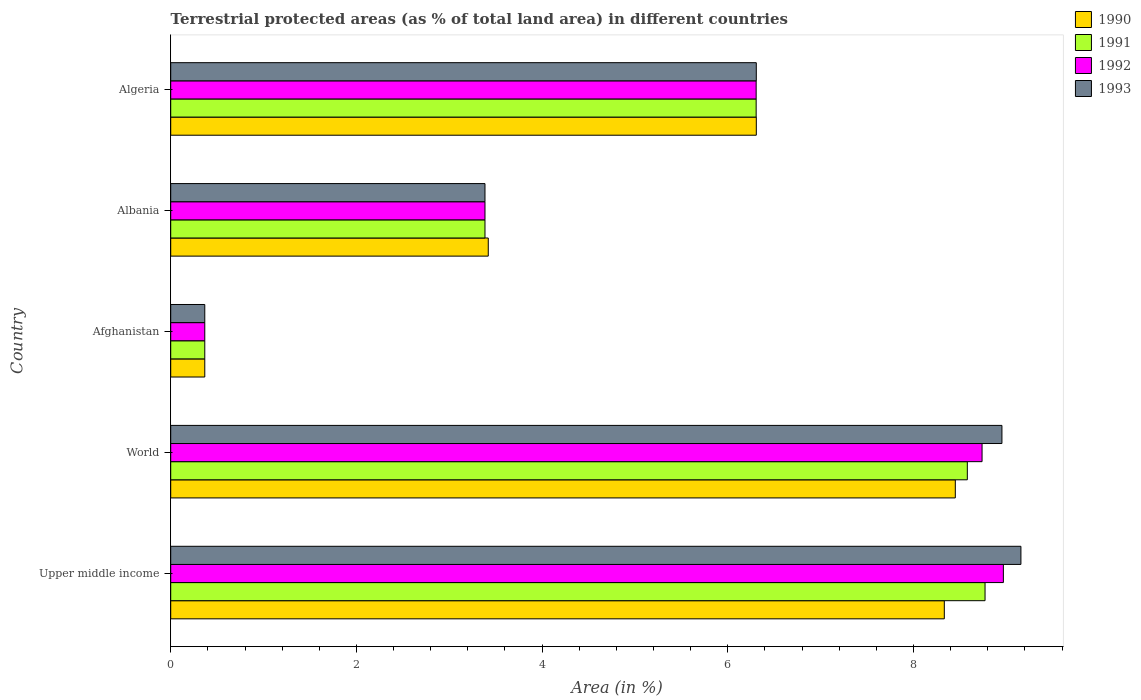How many different coloured bars are there?
Give a very brief answer. 4. How many bars are there on the 5th tick from the top?
Give a very brief answer. 4. How many bars are there on the 2nd tick from the bottom?
Make the answer very short. 4. What is the label of the 3rd group of bars from the top?
Ensure brevity in your answer.  Afghanistan. What is the percentage of terrestrial protected land in 1990 in Algeria?
Your response must be concise. 6.31. Across all countries, what is the maximum percentage of terrestrial protected land in 1990?
Offer a very short reply. 8.45. Across all countries, what is the minimum percentage of terrestrial protected land in 1993?
Keep it short and to the point. 0.37. In which country was the percentage of terrestrial protected land in 1993 maximum?
Make the answer very short. Upper middle income. In which country was the percentage of terrestrial protected land in 1991 minimum?
Provide a succinct answer. Afghanistan. What is the total percentage of terrestrial protected land in 1992 in the graph?
Offer a very short reply. 27.76. What is the difference between the percentage of terrestrial protected land in 1992 in Albania and that in World?
Offer a very short reply. -5.35. What is the difference between the percentage of terrestrial protected land in 1993 in Afghanistan and the percentage of terrestrial protected land in 1992 in Algeria?
Provide a short and direct response. -5.94. What is the average percentage of terrestrial protected land in 1992 per country?
Ensure brevity in your answer.  5.55. What is the difference between the percentage of terrestrial protected land in 1992 and percentage of terrestrial protected land in 1991 in Albania?
Offer a very short reply. 0. What is the ratio of the percentage of terrestrial protected land in 1991 in Upper middle income to that in World?
Give a very brief answer. 1.02. Is the percentage of terrestrial protected land in 1991 in Afghanistan less than that in Upper middle income?
Provide a short and direct response. Yes. What is the difference between the highest and the second highest percentage of terrestrial protected land in 1990?
Offer a terse response. 0.12. What is the difference between the highest and the lowest percentage of terrestrial protected land in 1990?
Give a very brief answer. 8.08. Is the sum of the percentage of terrestrial protected land in 1990 in Albania and World greater than the maximum percentage of terrestrial protected land in 1992 across all countries?
Ensure brevity in your answer.  Yes. Is it the case that in every country, the sum of the percentage of terrestrial protected land in 1990 and percentage of terrestrial protected land in 1993 is greater than the sum of percentage of terrestrial protected land in 1992 and percentage of terrestrial protected land in 1991?
Your response must be concise. No. What does the 1st bar from the top in Algeria represents?
Provide a succinct answer. 1993. What is the difference between two consecutive major ticks on the X-axis?
Offer a very short reply. 2. Are the values on the major ticks of X-axis written in scientific E-notation?
Your answer should be very brief. No. How many legend labels are there?
Your answer should be very brief. 4. What is the title of the graph?
Make the answer very short. Terrestrial protected areas (as % of total land area) in different countries. What is the label or title of the X-axis?
Keep it short and to the point. Area (in %). What is the label or title of the Y-axis?
Ensure brevity in your answer.  Country. What is the Area (in %) in 1990 in Upper middle income?
Give a very brief answer. 8.33. What is the Area (in %) of 1991 in Upper middle income?
Give a very brief answer. 8.77. What is the Area (in %) in 1992 in Upper middle income?
Offer a very short reply. 8.97. What is the Area (in %) of 1993 in Upper middle income?
Offer a very short reply. 9.16. What is the Area (in %) of 1990 in World?
Provide a succinct answer. 8.45. What is the Area (in %) in 1991 in World?
Offer a very short reply. 8.58. What is the Area (in %) of 1992 in World?
Offer a very short reply. 8.74. What is the Area (in %) in 1993 in World?
Ensure brevity in your answer.  8.95. What is the Area (in %) of 1990 in Afghanistan?
Provide a succinct answer. 0.37. What is the Area (in %) in 1991 in Afghanistan?
Your response must be concise. 0.37. What is the Area (in %) in 1992 in Afghanistan?
Give a very brief answer. 0.37. What is the Area (in %) of 1993 in Afghanistan?
Give a very brief answer. 0.37. What is the Area (in %) in 1990 in Albania?
Your answer should be very brief. 3.42. What is the Area (in %) of 1991 in Albania?
Your response must be concise. 3.38. What is the Area (in %) in 1992 in Albania?
Your response must be concise. 3.38. What is the Area (in %) of 1993 in Albania?
Provide a succinct answer. 3.38. What is the Area (in %) of 1990 in Algeria?
Make the answer very short. 6.31. What is the Area (in %) of 1991 in Algeria?
Offer a terse response. 6.31. What is the Area (in %) of 1992 in Algeria?
Ensure brevity in your answer.  6.31. What is the Area (in %) in 1993 in Algeria?
Give a very brief answer. 6.31. Across all countries, what is the maximum Area (in %) in 1990?
Make the answer very short. 8.45. Across all countries, what is the maximum Area (in %) of 1991?
Provide a short and direct response. 8.77. Across all countries, what is the maximum Area (in %) of 1992?
Offer a very short reply. 8.97. Across all countries, what is the maximum Area (in %) of 1993?
Provide a short and direct response. 9.16. Across all countries, what is the minimum Area (in %) of 1990?
Your answer should be very brief. 0.37. Across all countries, what is the minimum Area (in %) of 1991?
Offer a terse response. 0.37. Across all countries, what is the minimum Area (in %) in 1992?
Provide a short and direct response. 0.37. Across all countries, what is the minimum Area (in %) of 1993?
Keep it short and to the point. 0.37. What is the total Area (in %) of 1990 in the graph?
Keep it short and to the point. 26.88. What is the total Area (in %) of 1991 in the graph?
Offer a very short reply. 27.41. What is the total Area (in %) in 1992 in the graph?
Provide a succinct answer. 27.76. What is the total Area (in %) in 1993 in the graph?
Give a very brief answer. 28.17. What is the difference between the Area (in %) in 1990 in Upper middle income and that in World?
Your response must be concise. -0.12. What is the difference between the Area (in %) of 1991 in Upper middle income and that in World?
Offer a very short reply. 0.19. What is the difference between the Area (in %) of 1992 in Upper middle income and that in World?
Your answer should be compact. 0.23. What is the difference between the Area (in %) of 1993 in Upper middle income and that in World?
Offer a terse response. 0.2. What is the difference between the Area (in %) of 1990 in Upper middle income and that in Afghanistan?
Your answer should be very brief. 7.97. What is the difference between the Area (in %) of 1991 in Upper middle income and that in Afghanistan?
Offer a terse response. 8.4. What is the difference between the Area (in %) of 1992 in Upper middle income and that in Afghanistan?
Your answer should be very brief. 8.6. What is the difference between the Area (in %) in 1993 in Upper middle income and that in Afghanistan?
Give a very brief answer. 8.79. What is the difference between the Area (in %) of 1990 in Upper middle income and that in Albania?
Ensure brevity in your answer.  4.91. What is the difference between the Area (in %) in 1991 in Upper middle income and that in Albania?
Ensure brevity in your answer.  5.39. What is the difference between the Area (in %) in 1992 in Upper middle income and that in Albania?
Ensure brevity in your answer.  5.58. What is the difference between the Area (in %) of 1993 in Upper middle income and that in Albania?
Your response must be concise. 5.77. What is the difference between the Area (in %) of 1990 in Upper middle income and that in Algeria?
Your answer should be very brief. 2.02. What is the difference between the Area (in %) of 1991 in Upper middle income and that in Algeria?
Your response must be concise. 2.47. What is the difference between the Area (in %) of 1992 in Upper middle income and that in Algeria?
Provide a succinct answer. 2.66. What is the difference between the Area (in %) in 1993 in Upper middle income and that in Algeria?
Offer a very short reply. 2.85. What is the difference between the Area (in %) in 1990 in World and that in Afghanistan?
Offer a very short reply. 8.08. What is the difference between the Area (in %) of 1991 in World and that in Afghanistan?
Keep it short and to the point. 8.21. What is the difference between the Area (in %) in 1992 in World and that in Afghanistan?
Provide a short and direct response. 8.37. What is the difference between the Area (in %) in 1993 in World and that in Afghanistan?
Provide a succinct answer. 8.59. What is the difference between the Area (in %) of 1990 in World and that in Albania?
Provide a short and direct response. 5.03. What is the difference between the Area (in %) in 1991 in World and that in Albania?
Offer a very short reply. 5.2. What is the difference between the Area (in %) of 1992 in World and that in Albania?
Your answer should be very brief. 5.35. What is the difference between the Area (in %) in 1993 in World and that in Albania?
Provide a short and direct response. 5.57. What is the difference between the Area (in %) of 1990 in World and that in Algeria?
Keep it short and to the point. 2.14. What is the difference between the Area (in %) of 1991 in World and that in Algeria?
Provide a short and direct response. 2.27. What is the difference between the Area (in %) of 1992 in World and that in Algeria?
Your response must be concise. 2.43. What is the difference between the Area (in %) in 1993 in World and that in Algeria?
Make the answer very short. 2.65. What is the difference between the Area (in %) in 1990 in Afghanistan and that in Albania?
Your answer should be very brief. -3.05. What is the difference between the Area (in %) in 1991 in Afghanistan and that in Albania?
Your response must be concise. -3.02. What is the difference between the Area (in %) in 1992 in Afghanistan and that in Albania?
Provide a short and direct response. -3.02. What is the difference between the Area (in %) in 1993 in Afghanistan and that in Albania?
Give a very brief answer. -3.02. What is the difference between the Area (in %) of 1990 in Afghanistan and that in Algeria?
Make the answer very short. -5.94. What is the difference between the Area (in %) in 1991 in Afghanistan and that in Algeria?
Ensure brevity in your answer.  -5.94. What is the difference between the Area (in %) of 1992 in Afghanistan and that in Algeria?
Keep it short and to the point. -5.94. What is the difference between the Area (in %) of 1993 in Afghanistan and that in Algeria?
Provide a short and direct response. -5.94. What is the difference between the Area (in %) in 1990 in Albania and that in Algeria?
Provide a short and direct response. -2.89. What is the difference between the Area (in %) of 1991 in Albania and that in Algeria?
Offer a very short reply. -2.92. What is the difference between the Area (in %) in 1992 in Albania and that in Algeria?
Provide a short and direct response. -2.92. What is the difference between the Area (in %) of 1993 in Albania and that in Algeria?
Provide a succinct answer. -2.92. What is the difference between the Area (in %) in 1990 in Upper middle income and the Area (in %) in 1991 in World?
Offer a very short reply. -0.25. What is the difference between the Area (in %) in 1990 in Upper middle income and the Area (in %) in 1992 in World?
Provide a short and direct response. -0.41. What is the difference between the Area (in %) of 1990 in Upper middle income and the Area (in %) of 1993 in World?
Your response must be concise. -0.62. What is the difference between the Area (in %) of 1991 in Upper middle income and the Area (in %) of 1992 in World?
Give a very brief answer. 0.03. What is the difference between the Area (in %) in 1991 in Upper middle income and the Area (in %) in 1993 in World?
Keep it short and to the point. -0.18. What is the difference between the Area (in %) in 1992 in Upper middle income and the Area (in %) in 1993 in World?
Your response must be concise. 0.02. What is the difference between the Area (in %) of 1990 in Upper middle income and the Area (in %) of 1991 in Afghanistan?
Your response must be concise. 7.97. What is the difference between the Area (in %) in 1990 in Upper middle income and the Area (in %) in 1992 in Afghanistan?
Provide a short and direct response. 7.97. What is the difference between the Area (in %) in 1990 in Upper middle income and the Area (in %) in 1993 in Afghanistan?
Your response must be concise. 7.97. What is the difference between the Area (in %) of 1991 in Upper middle income and the Area (in %) of 1992 in Afghanistan?
Offer a very short reply. 8.4. What is the difference between the Area (in %) of 1991 in Upper middle income and the Area (in %) of 1993 in Afghanistan?
Your answer should be very brief. 8.4. What is the difference between the Area (in %) of 1992 in Upper middle income and the Area (in %) of 1993 in Afghanistan?
Ensure brevity in your answer.  8.6. What is the difference between the Area (in %) of 1990 in Upper middle income and the Area (in %) of 1991 in Albania?
Your answer should be very brief. 4.95. What is the difference between the Area (in %) of 1990 in Upper middle income and the Area (in %) of 1992 in Albania?
Provide a succinct answer. 4.95. What is the difference between the Area (in %) in 1990 in Upper middle income and the Area (in %) in 1993 in Albania?
Keep it short and to the point. 4.95. What is the difference between the Area (in %) of 1991 in Upper middle income and the Area (in %) of 1992 in Albania?
Give a very brief answer. 5.39. What is the difference between the Area (in %) in 1991 in Upper middle income and the Area (in %) in 1993 in Albania?
Give a very brief answer. 5.39. What is the difference between the Area (in %) in 1992 in Upper middle income and the Area (in %) in 1993 in Albania?
Your answer should be compact. 5.58. What is the difference between the Area (in %) of 1990 in Upper middle income and the Area (in %) of 1991 in Algeria?
Your answer should be very brief. 2.03. What is the difference between the Area (in %) in 1990 in Upper middle income and the Area (in %) in 1992 in Algeria?
Your answer should be very brief. 2.03. What is the difference between the Area (in %) in 1990 in Upper middle income and the Area (in %) in 1993 in Algeria?
Your answer should be compact. 2.03. What is the difference between the Area (in %) in 1991 in Upper middle income and the Area (in %) in 1992 in Algeria?
Provide a short and direct response. 2.47. What is the difference between the Area (in %) in 1991 in Upper middle income and the Area (in %) in 1993 in Algeria?
Ensure brevity in your answer.  2.46. What is the difference between the Area (in %) in 1992 in Upper middle income and the Area (in %) in 1993 in Algeria?
Make the answer very short. 2.66. What is the difference between the Area (in %) of 1990 in World and the Area (in %) of 1991 in Afghanistan?
Your response must be concise. 8.08. What is the difference between the Area (in %) of 1990 in World and the Area (in %) of 1992 in Afghanistan?
Give a very brief answer. 8.08. What is the difference between the Area (in %) of 1990 in World and the Area (in %) of 1993 in Afghanistan?
Give a very brief answer. 8.08. What is the difference between the Area (in %) in 1991 in World and the Area (in %) in 1992 in Afghanistan?
Your response must be concise. 8.21. What is the difference between the Area (in %) of 1991 in World and the Area (in %) of 1993 in Afghanistan?
Make the answer very short. 8.21. What is the difference between the Area (in %) of 1992 in World and the Area (in %) of 1993 in Afghanistan?
Offer a very short reply. 8.37. What is the difference between the Area (in %) of 1990 in World and the Area (in %) of 1991 in Albania?
Make the answer very short. 5.07. What is the difference between the Area (in %) in 1990 in World and the Area (in %) in 1992 in Albania?
Offer a terse response. 5.07. What is the difference between the Area (in %) of 1990 in World and the Area (in %) of 1993 in Albania?
Your response must be concise. 5.07. What is the difference between the Area (in %) in 1991 in World and the Area (in %) in 1992 in Albania?
Keep it short and to the point. 5.2. What is the difference between the Area (in %) in 1991 in World and the Area (in %) in 1993 in Albania?
Offer a terse response. 5.2. What is the difference between the Area (in %) in 1992 in World and the Area (in %) in 1993 in Albania?
Your answer should be compact. 5.35. What is the difference between the Area (in %) in 1990 in World and the Area (in %) in 1991 in Algeria?
Ensure brevity in your answer.  2.14. What is the difference between the Area (in %) of 1990 in World and the Area (in %) of 1992 in Algeria?
Your response must be concise. 2.14. What is the difference between the Area (in %) of 1990 in World and the Area (in %) of 1993 in Algeria?
Offer a very short reply. 2.14. What is the difference between the Area (in %) of 1991 in World and the Area (in %) of 1992 in Algeria?
Your answer should be very brief. 2.27. What is the difference between the Area (in %) in 1991 in World and the Area (in %) in 1993 in Algeria?
Offer a terse response. 2.27. What is the difference between the Area (in %) in 1992 in World and the Area (in %) in 1993 in Algeria?
Your answer should be very brief. 2.43. What is the difference between the Area (in %) of 1990 in Afghanistan and the Area (in %) of 1991 in Albania?
Ensure brevity in your answer.  -3.02. What is the difference between the Area (in %) in 1990 in Afghanistan and the Area (in %) in 1992 in Albania?
Your answer should be very brief. -3.02. What is the difference between the Area (in %) in 1990 in Afghanistan and the Area (in %) in 1993 in Albania?
Ensure brevity in your answer.  -3.02. What is the difference between the Area (in %) of 1991 in Afghanistan and the Area (in %) of 1992 in Albania?
Provide a short and direct response. -3.02. What is the difference between the Area (in %) in 1991 in Afghanistan and the Area (in %) in 1993 in Albania?
Your answer should be compact. -3.02. What is the difference between the Area (in %) of 1992 in Afghanistan and the Area (in %) of 1993 in Albania?
Your answer should be compact. -3.02. What is the difference between the Area (in %) in 1990 in Afghanistan and the Area (in %) in 1991 in Algeria?
Your answer should be very brief. -5.94. What is the difference between the Area (in %) of 1990 in Afghanistan and the Area (in %) of 1992 in Algeria?
Your answer should be very brief. -5.94. What is the difference between the Area (in %) in 1990 in Afghanistan and the Area (in %) in 1993 in Algeria?
Offer a terse response. -5.94. What is the difference between the Area (in %) in 1991 in Afghanistan and the Area (in %) in 1992 in Algeria?
Make the answer very short. -5.94. What is the difference between the Area (in %) of 1991 in Afghanistan and the Area (in %) of 1993 in Algeria?
Make the answer very short. -5.94. What is the difference between the Area (in %) of 1992 in Afghanistan and the Area (in %) of 1993 in Algeria?
Your answer should be compact. -5.94. What is the difference between the Area (in %) in 1990 in Albania and the Area (in %) in 1991 in Algeria?
Your answer should be very brief. -2.89. What is the difference between the Area (in %) in 1990 in Albania and the Area (in %) in 1992 in Algeria?
Provide a succinct answer. -2.89. What is the difference between the Area (in %) of 1990 in Albania and the Area (in %) of 1993 in Algeria?
Keep it short and to the point. -2.89. What is the difference between the Area (in %) of 1991 in Albania and the Area (in %) of 1992 in Algeria?
Keep it short and to the point. -2.92. What is the difference between the Area (in %) of 1991 in Albania and the Area (in %) of 1993 in Algeria?
Provide a succinct answer. -2.92. What is the difference between the Area (in %) in 1992 in Albania and the Area (in %) in 1993 in Algeria?
Make the answer very short. -2.92. What is the average Area (in %) in 1990 per country?
Your answer should be very brief. 5.38. What is the average Area (in %) in 1991 per country?
Offer a very short reply. 5.48. What is the average Area (in %) in 1992 per country?
Ensure brevity in your answer.  5.55. What is the average Area (in %) of 1993 per country?
Your answer should be compact. 5.63. What is the difference between the Area (in %) in 1990 and Area (in %) in 1991 in Upper middle income?
Your response must be concise. -0.44. What is the difference between the Area (in %) in 1990 and Area (in %) in 1992 in Upper middle income?
Make the answer very short. -0.64. What is the difference between the Area (in %) in 1990 and Area (in %) in 1993 in Upper middle income?
Provide a short and direct response. -0.83. What is the difference between the Area (in %) in 1991 and Area (in %) in 1992 in Upper middle income?
Keep it short and to the point. -0.2. What is the difference between the Area (in %) of 1991 and Area (in %) of 1993 in Upper middle income?
Your response must be concise. -0.39. What is the difference between the Area (in %) in 1992 and Area (in %) in 1993 in Upper middle income?
Ensure brevity in your answer.  -0.19. What is the difference between the Area (in %) of 1990 and Area (in %) of 1991 in World?
Provide a succinct answer. -0.13. What is the difference between the Area (in %) in 1990 and Area (in %) in 1992 in World?
Provide a short and direct response. -0.29. What is the difference between the Area (in %) in 1990 and Area (in %) in 1993 in World?
Give a very brief answer. -0.5. What is the difference between the Area (in %) of 1991 and Area (in %) of 1992 in World?
Ensure brevity in your answer.  -0.16. What is the difference between the Area (in %) in 1991 and Area (in %) in 1993 in World?
Keep it short and to the point. -0.37. What is the difference between the Area (in %) of 1992 and Area (in %) of 1993 in World?
Offer a very short reply. -0.21. What is the difference between the Area (in %) of 1990 and Area (in %) of 1993 in Afghanistan?
Provide a succinct answer. 0. What is the difference between the Area (in %) in 1991 and Area (in %) in 1992 in Afghanistan?
Give a very brief answer. 0. What is the difference between the Area (in %) of 1992 and Area (in %) of 1993 in Afghanistan?
Make the answer very short. 0. What is the difference between the Area (in %) of 1990 and Area (in %) of 1991 in Albania?
Offer a very short reply. 0.04. What is the difference between the Area (in %) of 1990 and Area (in %) of 1992 in Albania?
Offer a very short reply. 0.04. What is the difference between the Area (in %) in 1990 and Area (in %) in 1993 in Albania?
Provide a short and direct response. 0.04. What is the difference between the Area (in %) in 1991 and Area (in %) in 1993 in Albania?
Offer a very short reply. 0. What is the difference between the Area (in %) of 1990 and Area (in %) of 1991 in Algeria?
Your answer should be very brief. 0. What is the difference between the Area (in %) in 1990 and Area (in %) in 1992 in Algeria?
Provide a succinct answer. 0. What is the difference between the Area (in %) in 1991 and Area (in %) in 1992 in Algeria?
Make the answer very short. 0. What is the difference between the Area (in %) in 1991 and Area (in %) in 1993 in Algeria?
Make the answer very short. -0. What is the difference between the Area (in %) of 1992 and Area (in %) of 1993 in Algeria?
Give a very brief answer. -0. What is the ratio of the Area (in %) in 1991 in Upper middle income to that in World?
Ensure brevity in your answer.  1.02. What is the ratio of the Area (in %) in 1992 in Upper middle income to that in World?
Offer a terse response. 1.03. What is the ratio of the Area (in %) of 1993 in Upper middle income to that in World?
Your answer should be compact. 1.02. What is the ratio of the Area (in %) of 1990 in Upper middle income to that in Afghanistan?
Provide a succinct answer. 22.71. What is the ratio of the Area (in %) of 1991 in Upper middle income to that in Afghanistan?
Offer a very short reply. 23.91. What is the ratio of the Area (in %) in 1992 in Upper middle income to that in Afghanistan?
Your response must be concise. 24.44. What is the ratio of the Area (in %) of 1993 in Upper middle income to that in Afghanistan?
Make the answer very short. 24.96. What is the ratio of the Area (in %) of 1990 in Upper middle income to that in Albania?
Your response must be concise. 2.44. What is the ratio of the Area (in %) in 1991 in Upper middle income to that in Albania?
Keep it short and to the point. 2.59. What is the ratio of the Area (in %) in 1992 in Upper middle income to that in Albania?
Ensure brevity in your answer.  2.65. What is the ratio of the Area (in %) in 1993 in Upper middle income to that in Albania?
Keep it short and to the point. 2.71. What is the ratio of the Area (in %) of 1990 in Upper middle income to that in Algeria?
Provide a short and direct response. 1.32. What is the ratio of the Area (in %) of 1991 in Upper middle income to that in Algeria?
Offer a very short reply. 1.39. What is the ratio of the Area (in %) in 1992 in Upper middle income to that in Algeria?
Provide a short and direct response. 1.42. What is the ratio of the Area (in %) in 1993 in Upper middle income to that in Algeria?
Make the answer very short. 1.45. What is the ratio of the Area (in %) of 1990 in World to that in Afghanistan?
Provide a succinct answer. 23.03. What is the ratio of the Area (in %) of 1991 in World to that in Afghanistan?
Offer a very short reply. 23.39. What is the ratio of the Area (in %) of 1992 in World to that in Afghanistan?
Your answer should be very brief. 23.82. What is the ratio of the Area (in %) in 1993 in World to that in Afghanistan?
Your answer should be very brief. 24.4. What is the ratio of the Area (in %) of 1990 in World to that in Albania?
Make the answer very short. 2.47. What is the ratio of the Area (in %) in 1991 in World to that in Albania?
Give a very brief answer. 2.53. What is the ratio of the Area (in %) in 1992 in World to that in Albania?
Provide a succinct answer. 2.58. What is the ratio of the Area (in %) in 1993 in World to that in Albania?
Your answer should be very brief. 2.64. What is the ratio of the Area (in %) of 1990 in World to that in Algeria?
Provide a short and direct response. 1.34. What is the ratio of the Area (in %) in 1991 in World to that in Algeria?
Make the answer very short. 1.36. What is the ratio of the Area (in %) of 1992 in World to that in Algeria?
Your response must be concise. 1.39. What is the ratio of the Area (in %) of 1993 in World to that in Algeria?
Your answer should be very brief. 1.42. What is the ratio of the Area (in %) in 1990 in Afghanistan to that in Albania?
Your response must be concise. 0.11. What is the ratio of the Area (in %) in 1991 in Afghanistan to that in Albania?
Keep it short and to the point. 0.11. What is the ratio of the Area (in %) in 1992 in Afghanistan to that in Albania?
Give a very brief answer. 0.11. What is the ratio of the Area (in %) of 1993 in Afghanistan to that in Albania?
Keep it short and to the point. 0.11. What is the ratio of the Area (in %) in 1990 in Afghanistan to that in Algeria?
Offer a very short reply. 0.06. What is the ratio of the Area (in %) in 1991 in Afghanistan to that in Algeria?
Your answer should be very brief. 0.06. What is the ratio of the Area (in %) of 1992 in Afghanistan to that in Algeria?
Provide a succinct answer. 0.06. What is the ratio of the Area (in %) in 1993 in Afghanistan to that in Algeria?
Offer a terse response. 0.06. What is the ratio of the Area (in %) in 1990 in Albania to that in Algeria?
Keep it short and to the point. 0.54. What is the ratio of the Area (in %) in 1991 in Albania to that in Algeria?
Your answer should be very brief. 0.54. What is the ratio of the Area (in %) in 1992 in Albania to that in Algeria?
Your answer should be very brief. 0.54. What is the ratio of the Area (in %) in 1993 in Albania to that in Algeria?
Keep it short and to the point. 0.54. What is the difference between the highest and the second highest Area (in %) in 1990?
Make the answer very short. 0.12. What is the difference between the highest and the second highest Area (in %) of 1991?
Offer a terse response. 0.19. What is the difference between the highest and the second highest Area (in %) of 1992?
Give a very brief answer. 0.23. What is the difference between the highest and the second highest Area (in %) in 1993?
Give a very brief answer. 0.2. What is the difference between the highest and the lowest Area (in %) in 1990?
Offer a very short reply. 8.08. What is the difference between the highest and the lowest Area (in %) in 1991?
Your response must be concise. 8.4. What is the difference between the highest and the lowest Area (in %) in 1992?
Your answer should be compact. 8.6. What is the difference between the highest and the lowest Area (in %) of 1993?
Ensure brevity in your answer.  8.79. 